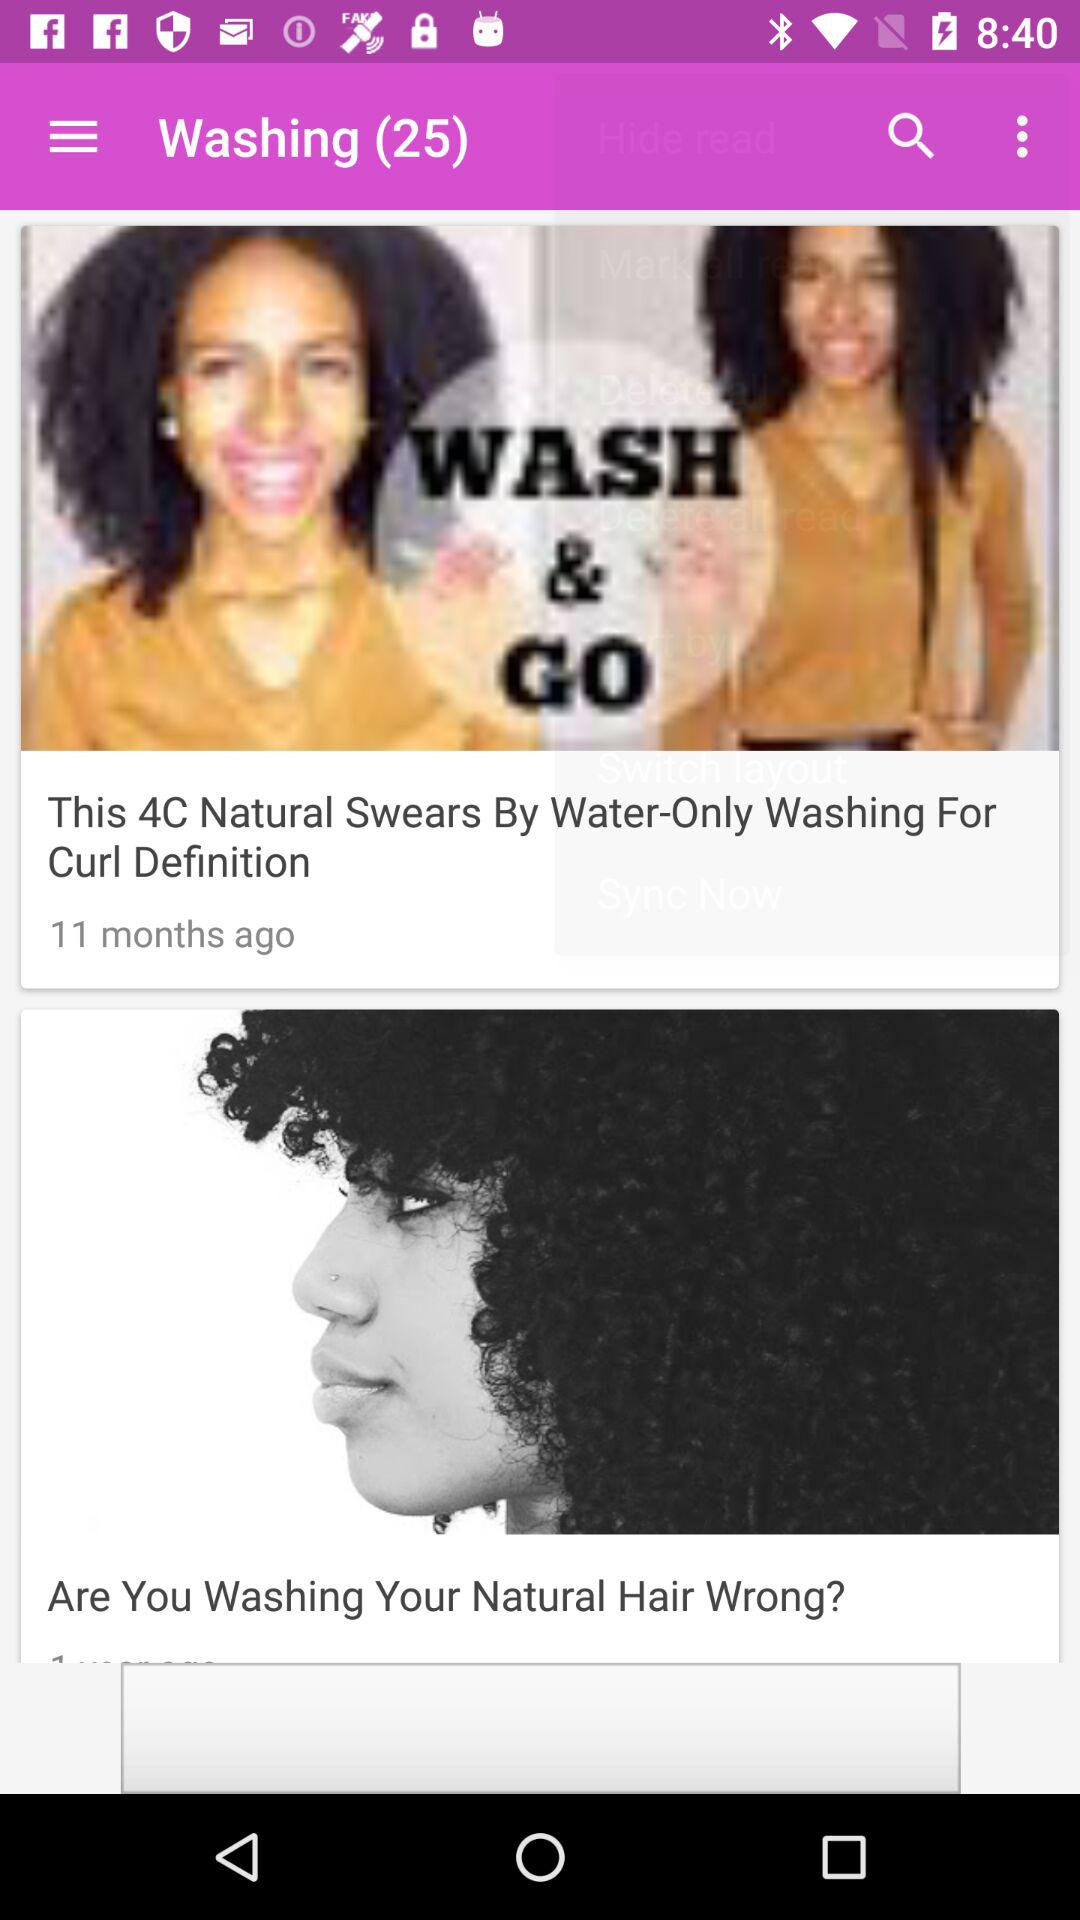How many months ago was the post posted? The post was posted 11 months ago. 